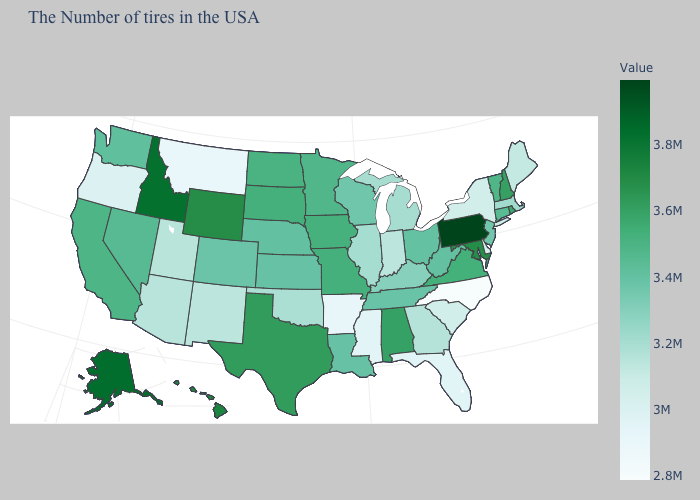Does the map have missing data?
Quick response, please. No. Does the map have missing data?
Give a very brief answer. No. Which states have the lowest value in the MidWest?
Be succinct. Indiana. Does Indiana have the highest value in the USA?
Keep it brief. No. Which states have the lowest value in the South?
Write a very short answer. North Carolina. Does Arizona have a lower value than Arkansas?
Write a very short answer. No. Is the legend a continuous bar?
Be succinct. Yes. Which states have the highest value in the USA?
Keep it brief. Pennsylvania. Does Wyoming have the lowest value in the West?
Concise answer only. No. Is the legend a continuous bar?
Quick response, please. Yes. 